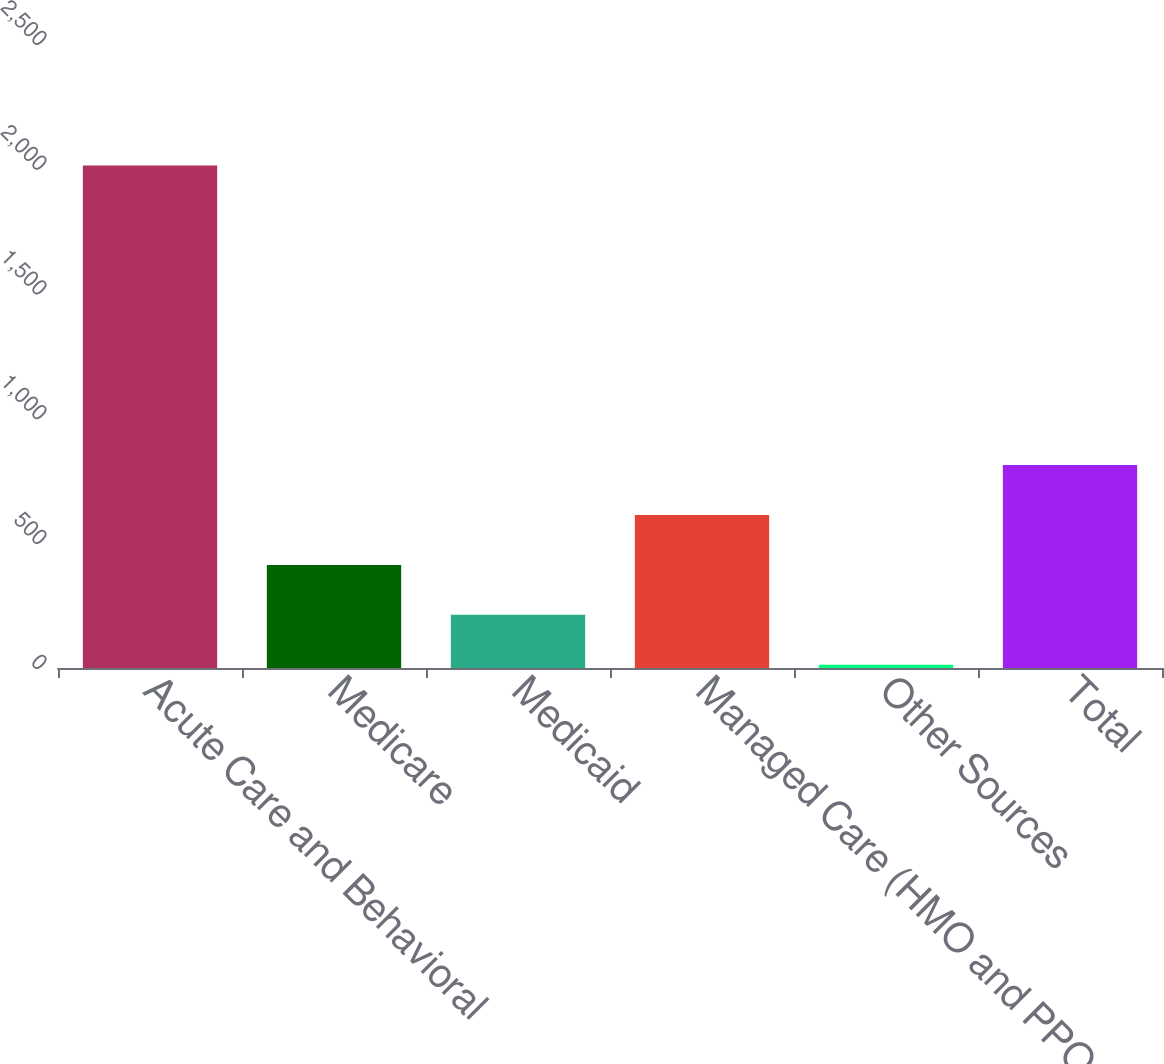Convert chart. <chart><loc_0><loc_0><loc_500><loc_500><bar_chart><fcel>Acute Care and Behavioral<fcel>Medicare<fcel>Medicaid<fcel>Managed Care (HMO and PPOs)<fcel>Other Sources<fcel>Total<nl><fcel>2013<fcel>413<fcel>213<fcel>613<fcel>13<fcel>813<nl></chart> 